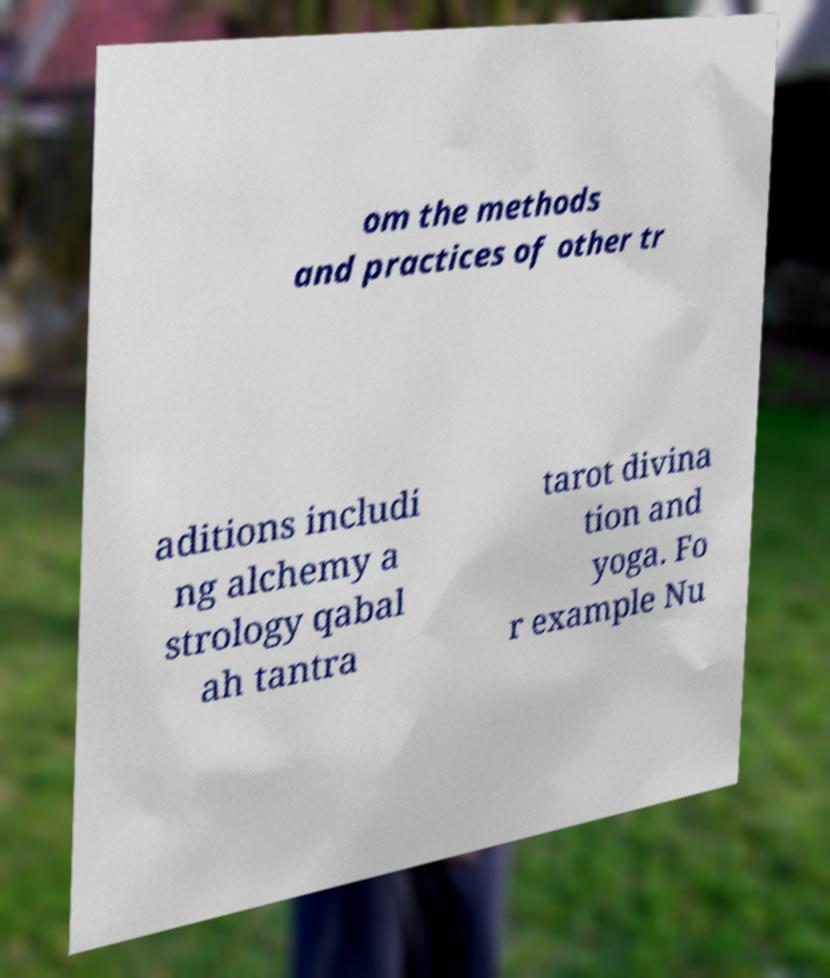Can you read and provide the text displayed in the image?This photo seems to have some interesting text. Can you extract and type it out for me? om the methods and practices of other tr aditions includi ng alchemy a strology qabal ah tantra tarot divina tion and yoga. Fo r example Nu 